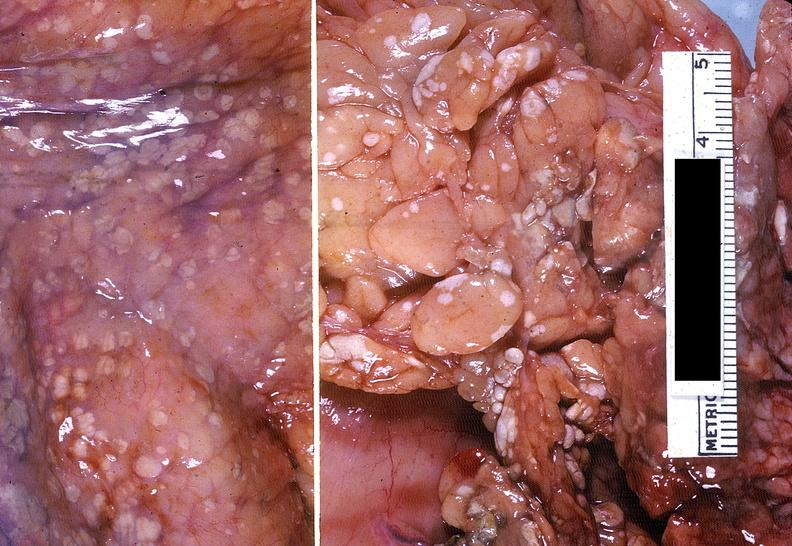does this image show acute pancreatitis with fat necrosis?
Answer the question using a single word or phrase. Yes 